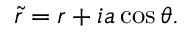Convert formula to latex. <formula><loc_0><loc_0><loc_500><loc_500>\tilde { r } = r + i a \cos \theta .</formula> 